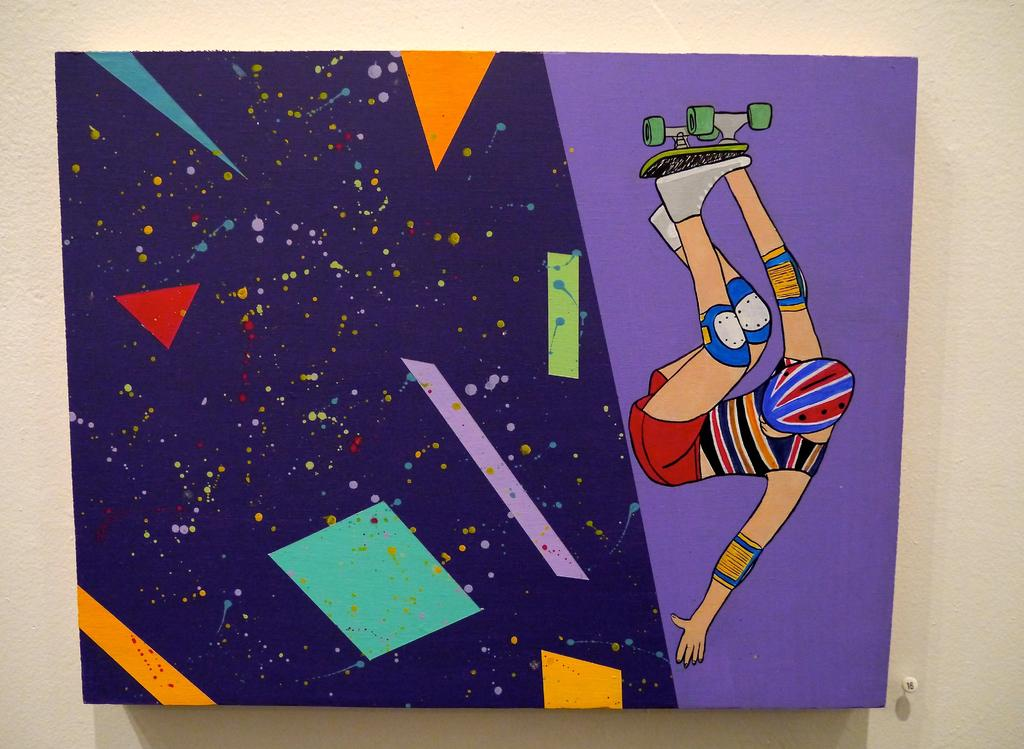What is the main subject of the image? The main subject of the image is a board painted with different colors. What can be seen in the background of the image? There is a wall in the background of the image. What is depicted on the wall? There is a painting of a person on the wall. Can you tell me what type of drum the doctor is playing at the playground in the image? There is no doctor, drum, or playground present in the image. 